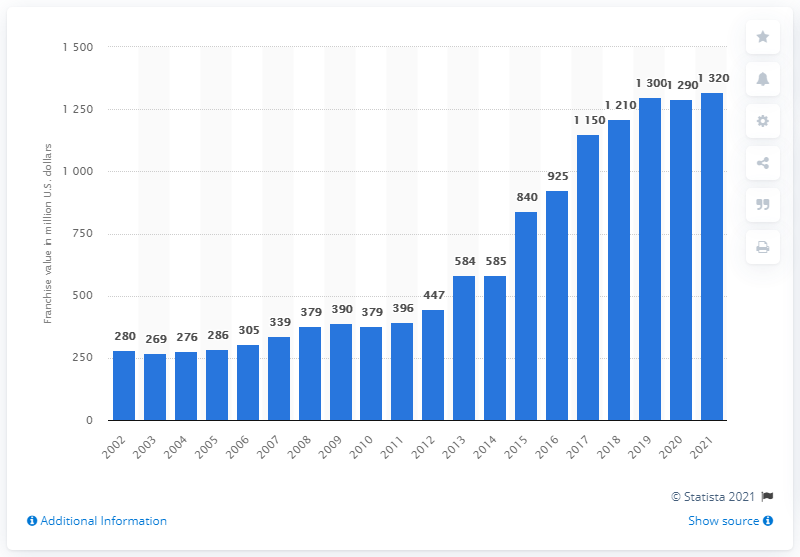Specify some key components in this picture. The estimated value of the Arizona Diamondbacks in 2021 was approximately $1320 million. 